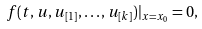Convert formula to latex. <formula><loc_0><loc_0><loc_500><loc_500>f ( t , u , u _ { [ 1 ] } , \dots , u _ { [ k ] } ) | _ { x = x _ { 0 } } = 0 ,</formula> 